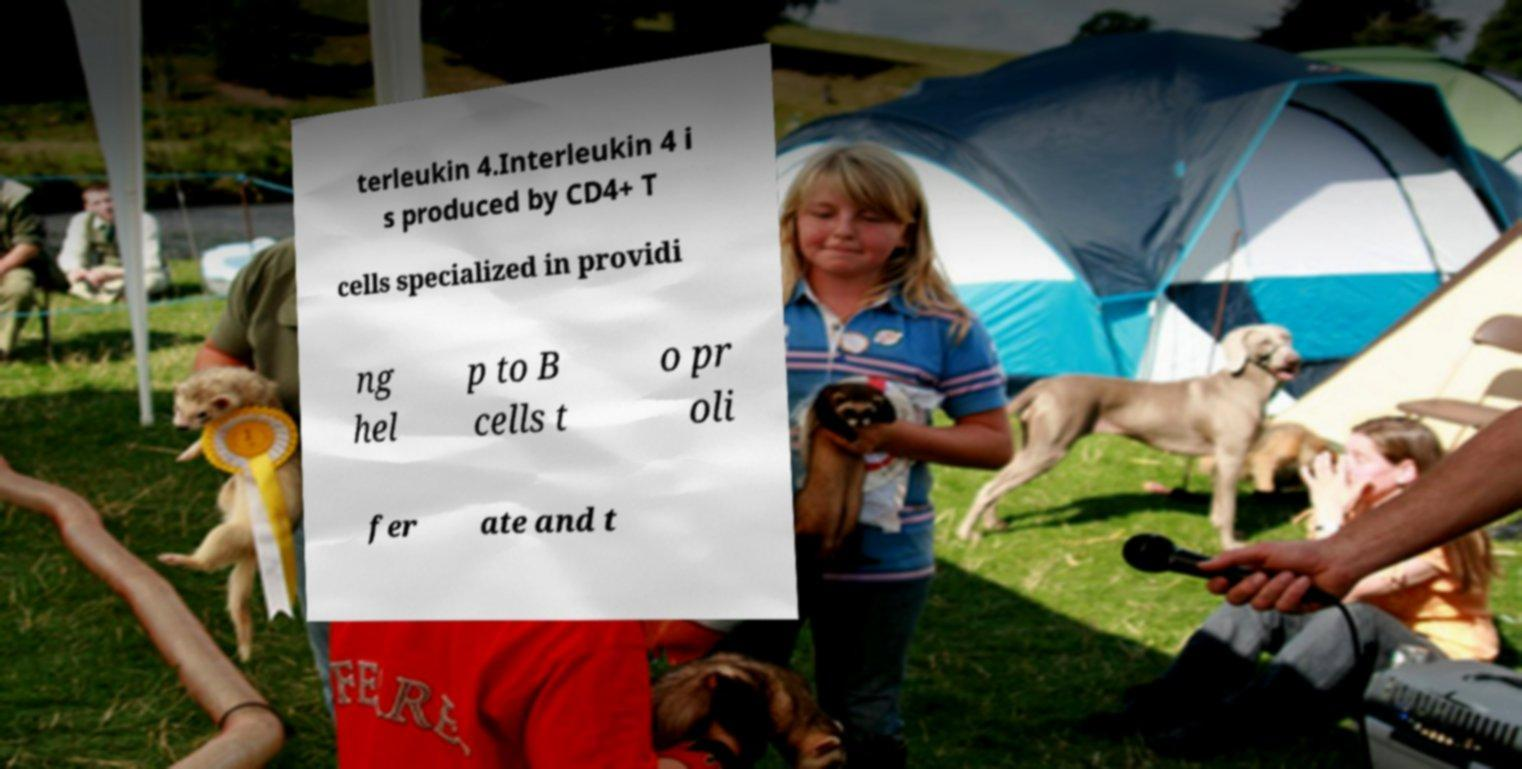Please read and relay the text visible in this image. What does it say? terleukin 4.Interleukin 4 i s produced by CD4+ T cells specialized in providi ng hel p to B cells t o pr oli fer ate and t 